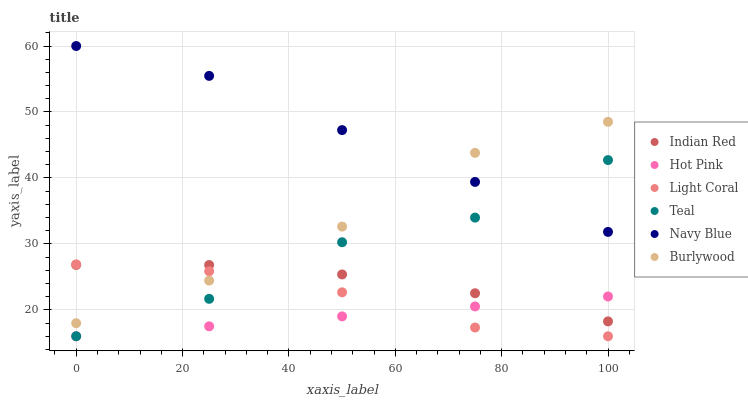Does Hot Pink have the minimum area under the curve?
Answer yes or no. Yes. Does Navy Blue have the maximum area under the curve?
Answer yes or no. Yes. Does Burlywood have the minimum area under the curve?
Answer yes or no. No. Does Burlywood have the maximum area under the curve?
Answer yes or no. No. Is Hot Pink the smoothest?
Answer yes or no. Yes. Is Teal the roughest?
Answer yes or no. Yes. Is Burlywood the smoothest?
Answer yes or no. No. Is Burlywood the roughest?
Answer yes or no. No. Does Hot Pink have the lowest value?
Answer yes or no. Yes. Does Burlywood have the lowest value?
Answer yes or no. No. Does Navy Blue have the highest value?
Answer yes or no. Yes. Does Burlywood have the highest value?
Answer yes or no. No. Is Light Coral less than Navy Blue?
Answer yes or no. Yes. Is Navy Blue greater than Indian Red?
Answer yes or no. Yes. Does Indian Red intersect Teal?
Answer yes or no. Yes. Is Indian Red less than Teal?
Answer yes or no. No. Is Indian Red greater than Teal?
Answer yes or no. No. Does Light Coral intersect Navy Blue?
Answer yes or no. No. 